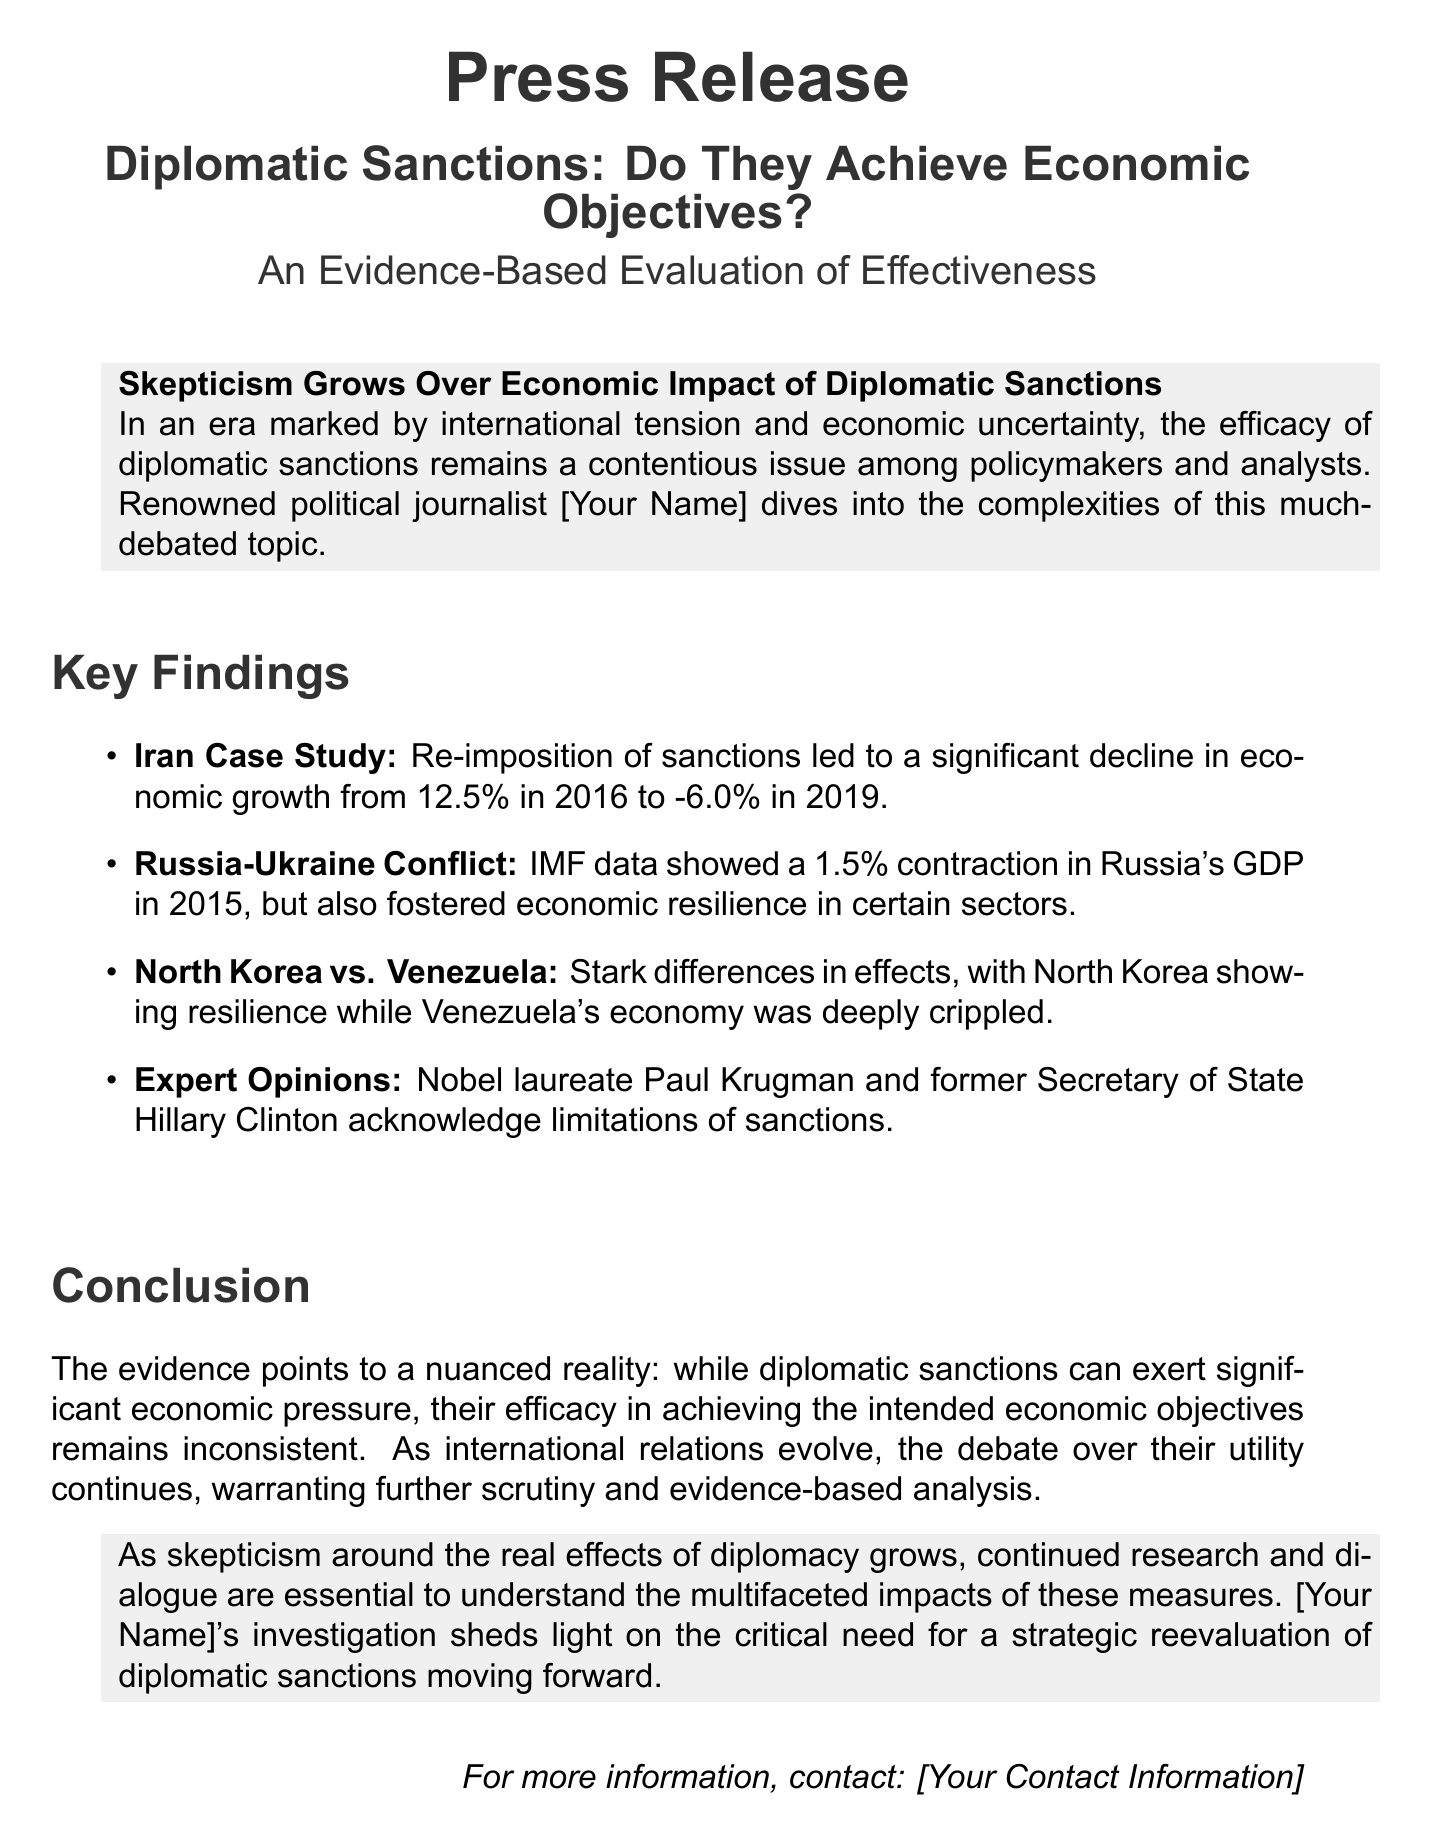What was the economic growth rate in Iran in 2016? The document states that the economic growth rate in Iran was 12.5% in 2016.
Answer: 12.5% What was Russia's GDP contraction in 2015? According to the IMF data presented, Russia's GDP contracted by 1.5% in 2015.
Answer: 1.5% What was the economic growth rate in Iran in 2019? The document indicates that the economic growth rate in Iran declined to -6.0% in 2019.
Answer: -6.0% Who acknowledged the limitations of sanctions? The document mentions that Paul Krugman and Hillary Clinton acknowledge the limitations of sanctions.
Answer: Paul Krugman and Hillary Clinton Which country showed economic resilience despite sanctions? The document highlights that North Korea showed resilience while other countries struggled.
Answer: North Korea What type of analysis is featured in the press release? The press release emphasizes an evidence-based evaluation of the effectiveness of sanctions.
Answer: Evidence-based evaluation What is the main conclusion regarding the efficacy of diplomatic sanctions? The document concludes that the efficacy of diplomatic sanctions remains inconsistent despite their potential to exert economic pressure.
Answer: Inconsistent What is the primary focus of [Your Name]'s investigation? The investigation focuses on the critical need for a strategic reevaluation of diplomatic sanctions.
Answer: Reevaluation of diplomatic sanctions What sector experienced resilience in Russia due to sanctions? The document states that certain sectors fostered economic resilience in Russia, but does not specify which ones.
Answer: Certain sectors 